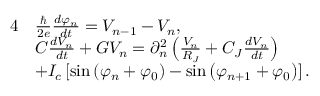Convert formula to latex. <formula><loc_0><loc_0><loc_500><loc_500>\begin{array} { r l } { 4 } & { \frac { } { 2 e } \frac { d \varphi _ { n } } { d t } = V _ { n - 1 } - V _ { n } , } \\ & { C \frac { d V _ { n } } { d t } + G V _ { n } = \partial _ { n } ^ { 2 } \left ( \frac { V _ { n } } { R _ { J } } + C _ { J } \frac { d V _ { n } } { d t } \right ) } \\ & { + I _ { c } \left [ \sin \left ( \varphi _ { n } + \varphi _ { 0 } \right ) - \sin \left ( \varphi _ { n + 1 } + \varphi _ { 0 } \right ) \right ] . } \end{array}</formula> 